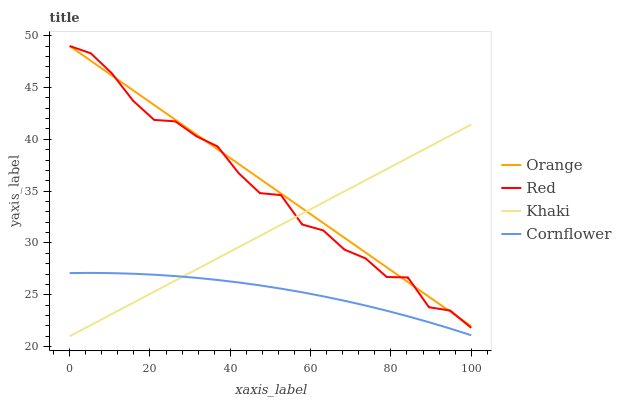Does Cornflower have the minimum area under the curve?
Answer yes or no. Yes. Does Orange have the maximum area under the curve?
Answer yes or no. Yes. Does Khaki have the minimum area under the curve?
Answer yes or no. No. Does Khaki have the maximum area under the curve?
Answer yes or no. No. Is Khaki the smoothest?
Answer yes or no. Yes. Is Red the roughest?
Answer yes or no. Yes. Is Cornflower the smoothest?
Answer yes or no. No. Is Cornflower the roughest?
Answer yes or no. No. Does Cornflower have the lowest value?
Answer yes or no. No. Does Red have the highest value?
Answer yes or no. Yes. Does Khaki have the highest value?
Answer yes or no. No. Is Cornflower less than Red?
Answer yes or no. Yes. Is Orange greater than Cornflower?
Answer yes or no. Yes. Does Cornflower intersect Khaki?
Answer yes or no. Yes. Is Cornflower less than Khaki?
Answer yes or no. No. Is Cornflower greater than Khaki?
Answer yes or no. No. Does Cornflower intersect Red?
Answer yes or no. No. 